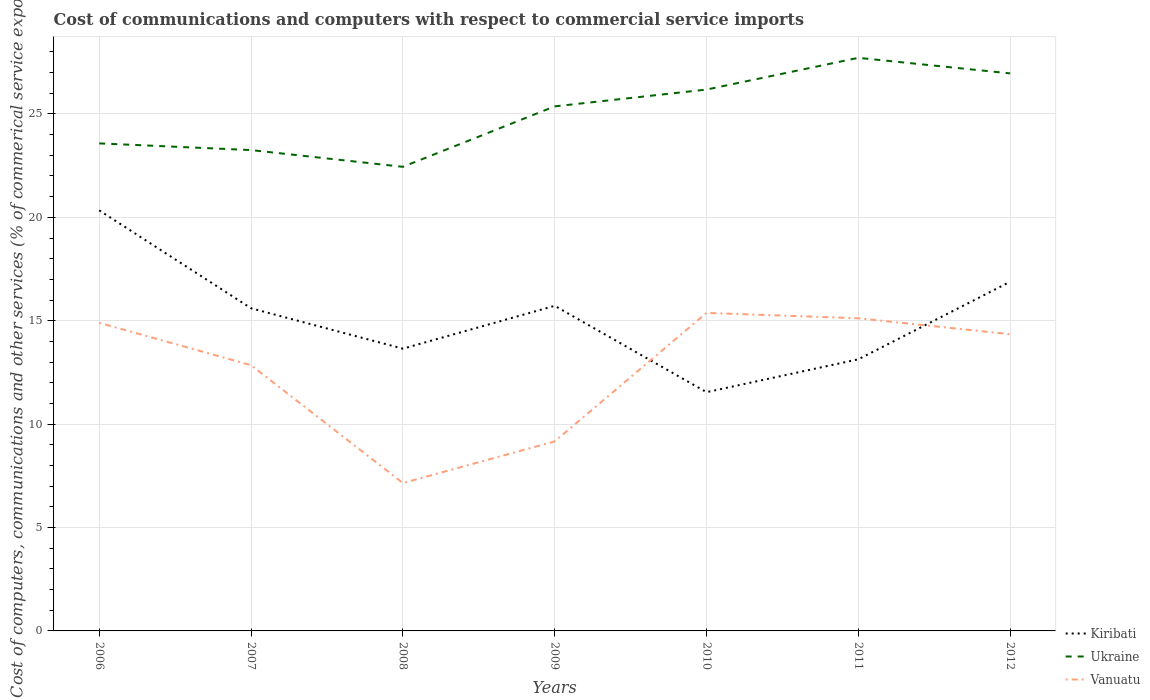Across all years, what is the maximum cost of communications and computers in Ukraine?
Make the answer very short. 22.44. What is the total cost of communications and computers in Vanuatu in the graph?
Offer a very short reply. -2.27. What is the difference between the highest and the second highest cost of communications and computers in Vanuatu?
Offer a very short reply. 8.23. What is the difference between the highest and the lowest cost of communications and computers in Kiribati?
Give a very brief answer. 4. Is the cost of communications and computers in Ukraine strictly greater than the cost of communications and computers in Kiribati over the years?
Your answer should be very brief. No. How many lines are there?
Provide a succinct answer. 3. How many years are there in the graph?
Your answer should be compact. 7. What is the difference between two consecutive major ticks on the Y-axis?
Keep it short and to the point. 5. Are the values on the major ticks of Y-axis written in scientific E-notation?
Keep it short and to the point. No. Does the graph contain any zero values?
Give a very brief answer. No. What is the title of the graph?
Make the answer very short. Cost of communications and computers with respect to commercial service imports. What is the label or title of the X-axis?
Your answer should be very brief. Years. What is the label or title of the Y-axis?
Keep it short and to the point. Cost of computers, communications and other services (% of commerical service exports). What is the Cost of computers, communications and other services (% of commerical service exports) of Kiribati in 2006?
Provide a succinct answer. 20.34. What is the Cost of computers, communications and other services (% of commerical service exports) in Ukraine in 2006?
Your answer should be compact. 23.58. What is the Cost of computers, communications and other services (% of commerical service exports) in Vanuatu in 2006?
Offer a very short reply. 14.9. What is the Cost of computers, communications and other services (% of commerical service exports) of Kiribati in 2007?
Give a very brief answer. 15.6. What is the Cost of computers, communications and other services (% of commerical service exports) in Ukraine in 2007?
Your answer should be very brief. 23.25. What is the Cost of computers, communications and other services (% of commerical service exports) of Vanuatu in 2007?
Your answer should be compact. 12.85. What is the Cost of computers, communications and other services (% of commerical service exports) in Kiribati in 2008?
Make the answer very short. 13.65. What is the Cost of computers, communications and other services (% of commerical service exports) of Ukraine in 2008?
Give a very brief answer. 22.44. What is the Cost of computers, communications and other services (% of commerical service exports) in Vanuatu in 2008?
Provide a succinct answer. 7.15. What is the Cost of computers, communications and other services (% of commerical service exports) in Kiribati in 2009?
Your answer should be very brief. 15.72. What is the Cost of computers, communications and other services (% of commerical service exports) in Ukraine in 2009?
Your answer should be very brief. 25.37. What is the Cost of computers, communications and other services (% of commerical service exports) in Vanuatu in 2009?
Your answer should be compact. 9.16. What is the Cost of computers, communications and other services (% of commerical service exports) in Kiribati in 2010?
Give a very brief answer. 11.55. What is the Cost of computers, communications and other services (% of commerical service exports) in Ukraine in 2010?
Ensure brevity in your answer.  26.18. What is the Cost of computers, communications and other services (% of commerical service exports) of Vanuatu in 2010?
Give a very brief answer. 15.38. What is the Cost of computers, communications and other services (% of commerical service exports) in Kiribati in 2011?
Your answer should be very brief. 13.13. What is the Cost of computers, communications and other services (% of commerical service exports) of Ukraine in 2011?
Your response must be concise. 27.71. What is the Cost of computers, communications and other services (% of commerical service exports) in Vanuatu in 2011?
Give a very brief answer. 15.12. What is the Cost of computers, communications and other services (% of commerical service exports) in Kiribati in 2012?
Make the answer very short. 16.89. What is the Cost of computers, communications and other services (% of commerical service exports) in Ukraine in 2012?
Make the answer very short. 26.96. What is the Cost of computers, communications and other services (% of commerical service exports) in Vanuatu in 2012?
Ensure brevity in your answer.  14.35. Across all years, what is the maximum Cost of computers, communications and other services (% of commerical service exports) in Kiribati?
Your answer should be very brief. 20.34. Across all years, what is the maximum Cost of computers, communications and other services (% of commerical service exports) of Ukraine?
Your answer should be compact. 27.71. Across all years, what is the maximum Cost of computers, communications and other services (% of commerical service exports) of Vanuatu?
Your answer should be very brief. 15.38. Across all years, what is the minimum Cost of computers, communications and other services (% of commerical service exports) in Kiribati?
Offer a very short reply. 11.55. Across all years, what is the minimum Cost of computers, communications and other services (% of commerical service exports) in Ukraine?
Your answer should be compact. 22.44. Across all years, what is the minimum Cost of computers, communications and other services (% of commerical service exports) in Vanuatu?
Provide a short and direct response. 7.15. What is the total Cost of computers, communications and other services (% of commerical service exports) of Kiribati in the graph?
Provide a succinct answer. 106.88. What is the total Cost of computers, communications and other services (% of commerical service exports) of Ukraine in the graph?
Your answer should be very brief. 175.49. What is the total Cost of computers, communications and other services (% of commerical service exports) in Vanuatu in the graph?
Offer a very short reply. 88.91. What is the difference between the Cost of computers, communications and other services (% of commerical service exports) in Kiribati in 2006 and that in 2007?
Offer a terse response. 4.73. What is the difference between the Cost of computers, communications and other services (% of commerical service exports) of Ukraine in 2006 and that in 2007?
Offer a very short reply. 0.32. What is the difference between the Cost of computers, communications and other services (% of commerical service exports) in Vanuatu in 2006 and that in 2007?
Provide a succinct answer. 2.05. What is the difference between the Cost of computers, communications and other services (% of commerical service exports) in Kiribati in 2006 and that in 2008?
Your response must be concise. 6.69. What is the difference between the Cost of computers, communications and other services (% of commerical service exports) of Ukraine in 2006 and that in 2008?
Provide a short and direct response. 1.13. What is the difference between the Cost of computers, communications and other services (% of commerical service exports) of Vanuatu in 2006 and that in 2008?
Offer a very short reply. 7.75. What is the difference between the Cost of computers, communications and other services (% of commerical service exports) in Kiribati in 2006 and that in 2009?
Make the answer very short. 4.62. What is the difference between the Cost of computers, communications and other services (% of commerical service exports) of Ukraine in 2006 and that in 2009?
Provide a short and direct response. -1.79. What is the difference between the Cost of computers, communications and other services (% of commerical service exports) of Vanuatu in 2006 and that in 2009?
Your answer should be compact. 5.73. What is the difference between the Cost of computers, communications and other services (% of commerical service exports) of Kiribati in 2006 and that in 2010?
Provide a short and direct response. 8.79. What is the difference between the Cost of computers, communications and other services (% of commerical service exports) of Ukraine in 2006 and that in 2010?
Provide a succinct answer. -2.6. What is the difference between the Cost of computers, communications and other services (% of commerical service exports) in Vanuatu in 2006 and that in 2010?
Provide a succinct answer. -0.48. What is the difference between the Cost of computers, communications and other services (% of commerical service exports) in Kiribati in 2006 and that in 2011?
Ensure brevity in your answer.  7.2. What is the difference between the Cost of computers, communications and other services (% of commerical service exports) in Ukraine in 2006 and that in 2011?
Keep it short and to the point. -4.14. What is the difference between the Cost of computers, communications and other services (% of commerical service exports) in Vanuatu in 2006 and that in 2011?
Ensure brevity in your answer.  -0.22. What is the difference between the Cost of computers, communications and other services (% of commerical service exports) of Kiribati in 2006 and that in 2012?
Your answer should be compact. 3.45. What is the difference between the Cost of computers, communications and other services (% of commerical service exports) in Ukraine in 2006 and that in 2012?
Keep it short and to the point. -3.39. What is the difference between the Cost of computers, communications and other services (% of commerical service exports) in Vanuatu in 2006 and that in 2012?
Offer a very short reply. 0.55. What is the difference between the Cost of computers, communications and other services (% of commerical service exports) in Kiribati in 2007 and that in 2008?
Ensure brevity in your answer.  1.95. What is the difference between the Cost of computers, communications and other services (% of commerical service exports) in Ukraine in 2007 and that in 2008?
Your answer should be compact. 0.81. What is the difference between the Cost of computers, communications and other services (% of commerical service exports) in Vanuatu in 2007 and that in 2008?
Ensure brevity in your answer.  5.7. What is the difference between the Cost of computers, communications and other services (% of commerical service exports) in Kiribati in 2007 and that in 2009?
Offer a terse response. -0.12. What is the difference between the Cost of computers, communications and other services (% of commerical service exports) in Ukraine in 2007 and that in 2009?
Make the answer very short. -2.11. What is the difference between the Cost of computers, communications and other services (% of commerical service exports) of Vanuatu in 2007 and that in 2009?
Your response must be concise. 3.68. What is the difference between the Cost of computers, communications and other services (% of commerical service exports) in Kiribati in 2007 and that in 2010?
Keep it short and to the point. 4.06. What is the difference between the Cost of computers, communications and other services (% of commerical service exports) of Ukraine in 2007 and that in 2010?
Your response must be concise. -2.93. What is the difference between the Cost of computers, communications and other services (% of commerical service exports) of Vanuatu in 2007 and that in 2010?
Make the answer very short. -2.53. What is the difference between the Cost of computers, communications and other services (% of commerical service exports) in Kiribati in 2007 and that in 2011?
Offer a very short reply. 2.47. What is the difference between the Cost of computers, communications and other services (% of commerical service exports) in Ukraine in 2007 and that in 2011?
Provide a short and direct response. -4.46. What is the difference between the Cost of computers, communications and other services (% of commerical service exports) in Vanuatu in 2007 and that in 2011?
Your answer should be very brief. -2.27. What is the difference between the Cost of computers, communications and other services (% of commerical service exports) of Kiribati in 2007 and that in 2012?
Keep it short and to the point. -1.28. What is the difference between the Cost of computers, communications and other services (% of commerical service exports) in Ukraine in 2007 and that in 2012?
Offer a terse response. -3.71. What is the difference between the Cost of computers, communications and other services (% of commerical service exports) of Vanuatu in 2007 and that in 2012?
Make the answer very short. -1.5. What is the difference between the Cost of computers, communications and other services (% of commerical service exports) of Kiribati in 2008 and that in 2009?
Your response must be concise. -2.07. What is the difference between the Cost of computers, communications and other services (% of commerical service exports) in Ukraine in 2008 and that in 2009?
Provide a short and direct response. -2.92. What is the difference between the Cost of computers, communications and other services (% of commerical service exports) of Vanuatu in 2008 and that in 2009?
Ensure brevity in your answer.  -2.01. What is the difference between the Cost of computers, communications and other services (% of commerical service exports) of Kiribati in 2008 and that in 2010?
Offer a terse response. 2.1. What is the difference between the Cost of computers, communications and other services (% of commerical service exports) of Ukraine in 2008 and that in 2010?
Your response must be concise. -3.74. What is the difference between the Cost of computers, communications and other services (% of commerical service exports) of Vanuatu in 2008 and that in 2010?
Give a very brief answer. -8.23. What is the difference between the Cost of computers, communications and other services (% of commerical service exports) of Kiribati in 2008 and that in 2011?
Keep it short and to the point. 0.52. What is the difference between the Cost of computers, communications and other services (% of commerical service exports) of Ukraine in 2008 and that in 2011?
Offer a very short reply. -5.27. What is the difference between the Cost of computers, communications and other services (% of commerical service exports) in Vanuatu in 2008 and that in 2011?
Offer a very short reply. -7.97. What is the difference between the Cost of computers, communications and other services (% of commerical service exports) in Kiribati in 2008 and that in 2012?
Make the answer very short. -3.24. What is the difference between the Cost of computers, communications and other services (% of commerical service exports) in Ukraine in 2008 and that in 2012?
Provide a short and direct response. -4.52. What is the difference between the Cost of computers, communications and other services (% of commerical service exports) of Vanuatu in 2008 and that in 2012?
Give a very brief answer. -7.2. What is the difference between the Cost of computers, communications and other services (% of commerical service exports) in Kiribati in 2009 and that in 2010?
Offer a terse response. 4.18. What is the difference between the Cost of computers, communications and other services (% of commerical service exports) in Ukraine in 2009 and that in 2010?
Ensure brevity in your answer.  -0.81. What is the difference between the Cost of computers, communications and other services (% of commerical service exports) of Vanuatu in 2009 and that in 2010?
Provide a short and direct response. -6.22. What is the difference between the Cost of computers, communications and other services (% of commerical service exports) of Kiribati in 2009 and that in 2011?
Give a very brief answer. 2.59. What is the difference between the Cost of computers, communications and other services (% of commerical service exports) of Ukraine in 2009 and that in 2011?
Your response must be concise. -2.35. What is the difference between the Cost of computers, communications and other services (% of commerical service exports) in Vanuatu in 2009 and that in 2011?
Keep it short and to the point. -5.95. What is the difference between the Cost of computers, communications and other services (% of commerical service exports) in Kiribati in 2009 and that in 2012?
Your response must be concise. -1.16. What is the difference between the Cost of computers, communications and other services (% of commerical service exports) of Ukraine in 2009 and that in 2012?
Keep it short and to the point. -1.6. What is the difference between the Cost of computers, communications and other services (% of commerical service exports) in Vanuatu in 2009 and that in 2012?
Offer a terse response. -5.18. What is the difference between the Cost of computers, communications and other services (% of commerical service exports) of Kiribati in 2010 and that in 2011?
Provide a short and direct response. -1.59. What is the difference between the Cost of computers, communications and other services (% of commerical service exports) in Ukraine in 2010 and that in 2011?
Provide a succinct answer. -1.53. What is the difference between the Cost of computers, communications and other services (% of commerical service exports) of Vanuatu in 2010 and that in 2011?
Give a very brief answer. 0.26. What is the difference between the Cost of computers, communications and other services (% of commerical service exports) of Kiribati in 2010 and that in 2012?
Give a very brief answer. -5.34. What is the difference between the Cost of computers, communications and other services (% of commerical service exports) of Ukraine in 2010 and that in 2012?
Provide a succinct answer. -0.78. What is the difference between the Cost of computers, communications and other services (% of commerical service exports) of Vanuatu in 2010 and that in 2012?
Give a very brief answer. 1.03. What is the difference between the Cost of computers, communications and other services (% of commerical service exports) of Kiribati in 2011 and that in 2012?
Provide a short and direct response. -3.75. What is the difference between the Cost of computers, communications and other services (% of commerical service exports) of Ukraine in 2011 and that in 2012?
Give a very brief answer. 0.75. What is the difference between the Cost of computers, communications and other services (% of commerical service exports) in Vanuatu in 2011 and that in 2012?
Ensure brevity in your answer.  0.77. What is the difference between the Cost of computers, communications and other services (% of commerical service exports) of Kiribati in 2006 and the Cost of computers, communications and other services (% of commerical service exports) of Ukraine in 2007?
Provide a succinct answer. -2.92. What is the difference between the Cost of computers, communications and other services (% of commerical service exports) of Kiribati in 2006 and the Cost of computers, communications and other services (% of commerical service exports) of Vanuatu in 2007?
Your answer should be very brief. 7.49. What is the difference between the Cost of computers, communications and other services (% of commerical service exports) in Ukraine in 2006 and the Cost of computers, communications and other services (% of commerical service exports) in Vanuatu in 2007?
Give a very brief answer. 10.73. What is the difference between the Cost of computers, communications and other services (% of commerical service exports) in Kiribati in 2006 and the Cost of computers, communications and other services (% of commerical service exports) in Ukraine in 2008?
Provide a short and direct response. -2.11. What is the difference between the Cost of computers, communications and other services (% of commerical service exports) of Kiribati in 2006 and the Cost of computers, communications and other services (% of commerical service exports) of Vanuatu in 2008?
Offer a terse response. 13.18. What is the difference between the Cost of computers, communications and other services (% of commerical service exports) of Ukraine in 2006 and the Cost of computers, communications and other services (% of commerical service exports) of Vanuatu in 2008?
Keep it short and to the point. 16.42. What is the difference between the Cost of computers, communications and other services (% of commerical service exports) in Kiribati in 2006 and the Cost of computers, communications and other services (% of commerical service exports) in Ukraine in 2009?
Your answer should be compact. -5.03. What is the difference between the Cost of computers, communications and other services (% of commerical service exports) of Kiribati in 2006 and the Cost of computers, communications and other services (% of commerical service exports) of Vanuatu in 2009?
Offer a terse response. 11.17. What is the difference between the Cost of computers, communications and other services (% of commerical service exports) of Ukraine in 2006 and the Cost of computers, communications and other services (% of commerical service exports) of Vanuatu in 2009?
Keep it short and to the point. 14.41. What is the difference between the Cost of computers, communications and other services (% of commerical service exports) of Kiribati in 2006 and the Cost of computers, communications and other services (% of commerical service exports) of Ukraine in 2010?
Your answer should be very brief. -5.84. What is the difference between the Cost of computers, communications and other services (% of commerical service exports) of Kiribati in 2006 and the Cost of computers, communications and other services (% of commerical service exports) of Vanuatu in 2010?
Your response must be concise. 4.96. What is the difference between the Cost of computers, communications and other services (% of commerical service exports) of Ukraine in 2006 and the Cost of computers, communications and other services (% of commerical service exports) of Vanuatu in 2010?
Provide a succinct answer. 8.2. What is the difference between the Cost of computers, communications and other services (% of commerical service exports) of Kiribati in 2006 and the Cost of computers, communications and other services (% of commerical service exports) of Ukraine in 2011?
Your response must be concise. -7.38. What is the difference between the Cost of computers, communications and other services (% of commerical service exports) of Kiribati in 2006 and the Cost of computers, communications and other services (% of commerical service exports) of Vanuatu in 2011?
Your response must be concise. 5.22. What is the difference between the Cost of computers, communications and other services (% of commerical service exports) in Ukraine in 2006 and the Cost of computers, communications and other services (% of commerical service exports) in Vanuatu in 2011?
Provide a short and direct response. 8.46. What is the difference between the Cost of computers, communications and other services (% of commerical service exports) of Kiribati in 2006 and the Cost of computers, communications and other services (% of commerical service exports) of Ukraine in 2012?
Your answer should be compact. -6.62. What is the difference between the Cost of computers, communications and other services (% of commerical service exports) in Kiribati in 2006 and the Cost of computers, communications and other services (% of commerical service exports) in Vanuatu in 2012?
Make the answer very short. 5.99. What is the difference between the Cost of computers, communications and other services (% of commerical service exports) of Ukraine in 2006 and the Cost of computers, communications and other services (% of commerical service exports) of Vanuatu in 2012?
Offer a terse response. 9.23. What is the difference between the Cost of computers, communications and other services (% of commerical service exports) in Kiribati in 2007 and the Cost of computers, communications and other services (% of commerical service exports) in Ukraine in 2008?
Make the answer very short. -6.84. What is the difference between the Cost of computers, communications and other services (% of commerical service exports) of Kiribati in 2007 and the Cost of computers, communications and other services (% of commerical service exports) of Vanuatu in 2008?
Your answer should be compact. 8.45. What is the difference between the Cost of computers, communications and other services (% of commerical service exports) in Ukraine in 2007 and the Cost of computers, communications and other services (% of commerical service exports) in Vanuatu in 2008?
Your answer should be compact. 16.1. What is the difference between the Cost of computers, communications and other services (% of commerical service exports) in Kiribati in 2007 and the Cost of computers, communications and other services (% of commerical service exports) in Ukraine in 2009?
Ensure brevity in your answer.  -9.76. What is the difference between the Cost of computers, communications and other services (% of commerical service exports) of Kiribati in 2007 and the Cost of computers, communications and other services (% of commerical service exports) of Vanuatu in 2009?
Make the answer very short. 6.44. What is the difference between the Cost of computers, communications and other services (% of commerical service exports) in Ukraine in 2007 and the Cost of computers, communications and other services (% of commerical service exports) in Vanuatu in 2009?
Give a very brief answer. 14.09. What is the difference between the Cost of computers, communications and other services (% of commerical service exports) of Kiribati in 2007 and the Cost of computers, communications and other services (% of commerical service exports) of Ukraine in 2010?
Provide a short and direct response. -10.58. What is the difference between the Cost of computers, communications and other services (% of commerical service exports) of Kiribati in 2007 and the Cost of computers, communications and other services (% of commerical service exports) of Vanuatu in 2010?
Your response must be concise. 0.22. What is the difference between the Cost of computers, communications and other services (% of commerical service exports) of Ukraine in 2007 and the Cost of computers, communications and other services (% of commerical service exports) of Vanuatu in 2010?
Keep it short and to the point. 7.87. What is the difference between the Cost of computers, communications and other services (% of commerical service exports) in Kiribati in 2007 and the Cost of computers, communications and other services (% of commerical service exports) in Ukraine in 2011?
Your response must be concise. -12.11. What is the difference between the Cost of computers, communications and other services (% of commerical service exports) of Kiribati in 2007 and the Cost of computers, communications and other services (% of commerical service exports) of Vanuatu in 2011?
Offer a terse response. 0.48. What is the difference between the Cost of computers, communications and other services (% of commerical service exports) in Ukraine in 2007 and the Cost of computers, communications and other services (% of commerical service exports) in Vanuatu in 2011?
Ensure brevity in your answer.  8.13. What is the difference between the Cost of computers, communications and other services (% of commerical service exports) of Kiribati in 2007 and the Cost of computers, communications and other services (% of commerical service exports) of Ukraine in 2012?
Offer a very short reply. -11.36. What is the difference between the Cost of computers, communications and other services (% of commerical service exports) of Kiribati in 2007 and the Cost of computers, communications and other services (% of commerical service exports) of Vanuatu in 2012?
Make the answer very short. 1.25. What is the difference between the Cost of computers, communications and other services (% of commerical service exports) in Ukraine in 2007 and the Cost of computers, communications and other services (% of commerical service exports) in Vanuatu in 2012?
Ensure brevity in your answer.  8.9. What is the difference between the Cost of computers, communications and other services (% of commerical service exports) of Kiribati in 2008 and the Cost of computers, communications and other services (% of commerical service exports) of Ukraine in 2009?
Offer a very short reply. -11.72. What is the difference between the Cost of computers, communications and other services (% of commerical service exports) in Kiribati in 2008 and the Cost of computers, communications and other services (% of commerical service exports) in Vanuatu in 2009?
Your response must be concise. 4.49. What is the difference between the Cost of computers, communications and other services (% of commerical service exports) of Ukraine in 2008 and the Cost of computers, communications and other services (% of commerical service exports) of Vanuatu in 2009?
Your response must be concise. 13.28. What is the difference between the Cost of computers, communications and other services (% of commerical service exports) in Kiribati in 2008 and the Cost of computers, communications and other services (% of commerical service exports) in Ukraine in 2010?
Your response must be concise. -12.53. What is the difference between the Cost of computers, communications and other services (% of commerical service exports) in Kiribati in 2008 and the Cost of computers, communications and other services (% of commerical service exports) in Vanuatu in 2010?
Your response must be concise. -1.73. What is the difference between the Cost of computers, communications and other services (% of commerical service exports) in Ukraine in 2008 and the Cost of computers, communications and other services (% of commerical service exports) in Vanuatu in 2010?
Provide a succinct answer. 7.06. What is the difference between the Cost of computers, communications and other services (% of commerical service exports) of Kiribati in 2008 and the Cost of computers, communications and other services (% of commerical service exports) of Ukraine in 2011?
Keep it short and to the point. -14.06. What is the difference between the Cost of computers, communications and other services (% of commerical service exports) in Kiribati in 2008 and the Cost of computers, communications and other services (% of commerical service exports) in Vanuatu in 2011?
Provide a short and direct response. -1.47. What is the difference between the Cost of computers, communications and other services (% of commerical service exports) in Ukraine in 2008 and the Cost of computers, communications and other services (% of commerical service exports) in Vanuatu in 2011?
Give a very brief answer. 7.32. What is the difference between the Cost of computers, communications and other services (% of commerical service exports) in Kiribati in 2008 and the Cost of computers, communications and other services (% of commerical service exports) in Ukraine in 2012?
Ensure brevity in your answer.  -13.31. What is the difference between the Cost of computers, communications and other services (% of commerical service exports) in Kiribati in 2008 and the Cost of computers, communications and other services (% of commerical service exports) in Vanuatu in 2012?
Offer a terse response. -0.7. What is the difference between the Cost of computers, communications and other services (% of commerical service exports) of Ukraine in 2008 and the Cost of computers, communications and other services (% of commerical service exports) of Vanuatu in 2012?
Your answer should be very brief. 8.1. What is the difference between the Cost of computers, communications and other services (% of commerical service exports) in Kiribati in 2009 and the Cost of computers, communications and other services (% of commerical service exports) in Ukraine in 2010?
Offer a very short reply. -10.46. What is the difference between the Cost of computers, communications and other services (% of commerical service exports) in Kiribati in 2009 and the Cost of computers, communications and other services (% of commerical service exports) in Vanuatu in 2010?
Provide a succinct answer. 0.34. What is the difference between the Cost of computers, communications and other services (% of commerical service exports) of Ukraine in 2009 and the Cost of computers, communications and other services (% of commerical service exports) of Vanuatu in 2010?
Your answer should be compact. 9.99. What is the difference between the Cost of computers, communications and other services (% of commerical service exports) of Kiribati in 2009 and the Cost of computers, communications and other services (% of commerical service exports) of Ukraine in 2011?
Your answer should be compact. -11.99. What is the difference between the Cost of computers, communications and other services (% of commerical service exports) in Kiribati in 2009 and the Cost of computers, communications and other services (% of commerical service exports) in Vanuatu in 2011?
Your answer should be very brief. 0.6. What is the difference between the Cost of computers, communications and other services (% of commerical service exports) in Ukraine in 2009 and the Cost of computers, communications and other services (% of commerical service exports) in Vanuatu in 2011?
Your answer should be compact. 10.25. What is the difference between the Cost of computers, communications and other services (% of commerical service exports) in Kiribati in 2009 and the Cost of computers, communications and other services (% of commerical service exports) in Ukraine in 2012?
Your answer should be very brief. -11.24. What is the difference between the Cost of computers, communications and other services (% of commerical service exports) in Kiribati in 2009 and the Cost of computers, communications and other services (% of commerical service exports) in Vanuatu in 2012?
Ensure brevity in your answer.  1.37. What is the difference between the Cost of computers, communications and other services (% of commerical service exports) in Ukraine in 2009 and the Cost of computers, communications and other services (% of commerical service exports) in Vanuatu in 2012?
Give a very brief answer. 11.02. What is the difference between the Cost of computers, communications and other services (% of commerical service exports) in Kiribati in 2010 and the Cost of computers, communications and other services (% of commerical service exports) in Ukraine in 2011?
Make the answer very short. -16.17. What is the difference between the Cost of computers, communications and other services (% of commerical service exports) in Kiribati in 2010 and the Cost of computers, communications and other services (% of commerical service exports) in Vanuatu in 2011?
Your response must be concise. -3.57. What is the difference between the Cost of computers, communications and other services (% of commerical service exports) of Ukraine in 2010 and the Cost of computers, communications and other services (% of commerical service exports) of Vanuatu in 2011?
Offer a very short reply. 11.06. What is the difference between the Cost of computers, communications and other services (% of commerical service exports) of Kiribati in 2010 and the Cost of computers, communications and other services (% of commerical service exports) of Ukraine in 2012?
Offer a terse response. -15.42. What is the difference between the Cost of computers, communications and other services (% of commerical service exports) of Kiribati in 2010 and the Cost of computers, communications and other services (% of commerical service exports) of Vanuatu in 2012?
Make the answer very short. -2.8. What is the difference between the Cost of computers, communications and other services (% of commerical service exports) in Ukraine in 2010 and the Cost of computers, communications and other services (% of commerical service exports) in Vanuatu in 2012?
Make the answer very short. 11.83. What is the difference between the Cost of computers, communications and other services (% of commerical service exports) in Kiribati in 2011 and the Cost of computers, communications and other services (% of commerical service exports) in Ukraine in 2012?
Provide a succinct answer. -13.83. What is the difference between the Cost of computers, communications and other services (% of commerical service exports) of Kiribati in 2011 and the Cost of computers, communications and other services (% of commerical service exports) of Vanuatu in 2012?
Offer a very short reply. -1.21. What is the difference between the Cost of computers, communications and other services (% of commerical service exports) in Ukraine in 2011 and the Cost of computers, communications and other services (% of commerical service exports) in Vanuatu in 2012?
Your answer should be compact. 13.37. What is the average Cost of computers, communications and other services (% of commerical service exports) of Kiribati per year?
Your response must be concise. 15.27. What is the average Cost of computers, communications and other services (% of commerical service exports) in Ukraine per year?
Your answer should be compact. 25.07. What is the average Cost of computers, communications and other services (% of commerical service exports) in Vanuatu per year?
Keep it short and to the point. 12.7. In the year 2006, what is the difference between the Cost of computers, communications and other services (% of commerical service exports) of Kiribati and Cost of computers, communications and other services (% of commerical service exports) of Ukraine?
Offer a very short reply. -3.24. In the year 2006, what is the difference between the Cost of computers, communications and other services (% of commerical service exports) of Kiribati and Cost of computers, communications and other services (% of commerical service exports) of Vanuatu?
Provide a short and direct response. 5.44. In the year 2006, what is the difference between the Cost of computers, communications and other services (% of commerical service exports) of Ukraine and Cost of computers, communications and other services (% of commerical service exports) of Vanuatu?
Your response must be concise. 8.68. In the year 2007, what is the difference between the Cost of computers, communications and other services (% of commerical service exports) in Kiribati and Cost of computers, communications and other services (% of commerical service exports) in Ukraine?
Your response must be concise. -7.65. In the year 2007, what is the difference between the Cost of computers, communications and other services (% of commerical service exports) in Kiribati and Cost of computers, communications and other services (% of commerical service exports) in Vanuatu?
Provide a short and direct response. 2.75. In the year 2007, what is the difference between the Cost of computers, communications and other services (% of commerical service exports) in Ukraine and Cost of computers, communications and other services (% of commerical service exports) in Vanuatu?
Your answer should be very brief. 10.4. In the year 2008, what is the difference between the Cost of computers, communications and other services (% of commerical service exports) of Kiribati and Cost of computers, communications and other services (% of commerical service exports) of Ukraine?
Your answer should be compact. -8.79. In the year 2008, what is the difference between the Cost of computers, communications and other services (% of commerical service exports) in Kiribati and Cost of computers, communications and other services (% of commerical service exports) in Vanuatu?
Provide a short and direct response. 6.5. In the year 2008, what is the difference between the Cost of computers, communications and other services (% of commerical service exports) in Ukraine and Cost of computers, communications and other services (% of commerical service exports) in Vanuatu?
Provide a succinct answer. 15.29. In the year 2009, what is the difference between the Cost of computers, communications and other services (% of commerical service exports) in Kiribati and Cost of computers, communications and other services (% of commerical service exports) in Ukraine?
Provide a succinct answer. -9.65. In the year 2009, what is the difference between the Cost of computers, communications and other services (% of commerical service exports) of Kiribati and Cost of computers, communications and other services (% of commerical service exports) of Vanuatu?
Your response must be concise. 6.56. In the year 2009, what is the difference between the Cost of computers, communications and other services (% of commerical service exports) in Ukraine and Cost of computers, communications and other services (% of commerical service exports) in Vanuatu?
Your response must be concise. 16.2. In the year 2010, what is the difference between the Cost of computers, communications and other services (% of commerical service exports) of Kiribati and Cost of computers, communications and other services (% of commerical service exports) of Ukraine?
Offer a very short reply. -14.63. In the year 2010, what is the difference between the Cost of computers, communications and other services (% of commerical service exports) of Kiribati and Cost of computers, communications and other services (% of commerical service exports) of Vanuatu?
Keep it short and to the point. -3.83. In the year 2010, what is the difference between the Cost of computers, communications and other services (% of commerical service exports) in Ukraine and Cost of computers, communications and other services (% of commerical service exports) in Vanuatu?
Provide a succinct answer. 10.8. In the year 2011, what is the difference between the Cost of computers, communications and other services (% of commerical service exports) of Kiribati and Cost of computers, communications and other services (% of commerical service exports) of Ukraine?
Offer a terse response. -14.58. In the year 2011, what is the difference between the Cost of computers, communications and other services (% of commerical service exports) of Kiribati and Cost of computers, communications and other services (% of commerical service exports) of Vanuatu?
Ensure brevity in your answer.  -1.98. In the year 2011, what is the difference between the Cost of computers, communications and other services (% of commerical service exports) of Ukraine and Cost of computers, communications and other services (% of commerical service exports) of Vanuatu?
Make the answer very short. 12.6. In the year 2012, what is the difference between the Cost of computers, communications and other services (% of commerical service exports) of Kiribati and Cost of computers, communications and other services (% of commerical service exports) of Ukraine?
Keep it short and to the point. -10.08. In the year 2012, what is the difference between the Cost of computers, communications and other services (% of commerical service exports) of Kiribati and Cost of computers, communications and other services (% of commerical service exports) of Vanuatu?
Offer a terse response. 2.54. In the year 2012, what is the difference between the Cost of computers, communications and other services (% of commerical service exports) in Ukraine and Cost of computers, communications and other services (% of commerical service exports) in Vanuatu?
Make the answer very short. 12.61. What is the ratio of the Cost of computers, communications and other services (% of commerical service exports) in Kiribati in 2006 to that in 2007?
Offer a terse response. 1.3. What is the ratio of the Cost of computers, communications and other services (% of commerical service exports) in Ukraine in 2006 to that in 2007?
Offer a terse response. 1.01. What is the ratio of the Cost of computers, communications and other services (% of commerical service exports) in Vanuatu in 2006 to that in 2007?
Your answer should be compact. 1.16. What is the ratio of the Cost of computers, communications and other services (% of commerical service exports) of Kiribati in 2006 to that in 2008?
Provide a short and direct response. 1.49. What is the ratio of the Cost of computers, communications and other services (% of commerical service exports) of Ukraine in 2006 to that in 2008?
Your response must be concise. 1.05. What is the ratio of the Cost of computers, communications and other services (% of commerical service exports) in Vanuatu in 2006 to that in 2008?
Provide a short and direct response. 2.08. What is the ratio of the Cost of computers, communications and other services (% of commerical service exports) of Kiribati in 2006 to that in 2009?
Offer a terse response. 1.29. What is the ratio of the Cost of computers, communications and other services (% of commerical service exports) in Ukraine in 2006 to that in 2009?
Ensure brevity in your answer.  0.93. What is the ratio of the Cost of computers, communications and other services (% of commerical service exports) of Vanuatu in 2006 to that in 2009?
Your answer should be very brief. 1.63. What is the ratio of the Cost of computers, communications and other services (% of commerical service exports) of Kiribati in 2006 to that in 2010?
Ensure brevity in your answer.  1.76. What is the ratio of the Cost of computers, communications and other services (% of commerical service exports) of Ukraine in 2006 to that in 2010?
Ensure brevity in your answer.  0.9. What is the ratio of the Cost of computers, communications and other services (% of commerical service exports) of Vanuatu in 2006 to that in 2010?
Ensure brevity in your answer.  0.97. What is the ratio of the Cost of computers, communications and other services (% of commerical service exports) of Kiribati in 2006 to that in 2011?
Provide a short and direct response. 1.55. What is the ratio of the Cost of computers, communications and other services (% of commerical service exports) in Ukraine in 2006 to that in 2011?
Offer a terse response. 0.85. What is the ratio of the Cost of computers, communications and other services (% of commerical service exports) in Vanuatu in 2006 to that in 2011?
Your answer should be compact. 0.99. What is the ratio of the Cost of computers, communications and other services (% of commerical service exports) of Kiribati in 2006 to that in 2012?
Give a very brief answer. 1.2. What is the ratio of the Cost of computers, communications and other services (% of commerical service exports) in Ukraine in 2006 to that in 2012?
Your response must be concise. 0.87. What is the ratio of the Cost of computers, communications and other services (% of commerical service exports) of Vanuatu in 2006 to that in 2012?
Keep it short and to the point. 1.04. What is the ratio of the Cost of computers, communications and other services (% of commerical service exports) in Kiribati in 2007 to that in 2008?
Make the answer very short. 1.14. What is the ratio of the Cost of computers, communications and other services (% of commerical service exports) in Ukraine in 2007 to that in 2008?
Your response must be concise. 1.04. What is the ratio of the Cost of computers, communications and other services (% of commerical service exports) in Vanuatu in 2007 to that in 2008?
Make the answer very short. 1.8. What is the ratio of the Cost of computers, communications and other services (% of commerical service exports) in Kiribati in 2007 to that in 2009?
Offer a terse response. 0.99. What is the ratio of the Cost of computers, communications and other services (% of commerical service exports) in Vanuatu in 2007 to that in 2009?
Your answer should be very brief. 1.4. What is the ratio of the Cost of computers, communications and other services (% of commerical service exports) in Kiribati in 2007 to that in 2010?
Provide a short and direct response. 1.35. What is the ratio of the Cost of computers, communications and other services (% of commerical service exports) in Ukraine in 2007 to that in 2010?
Your response must be concise. 0.89. What is the ratio of the Cost of computers, communications and other services (% of commerical service exports) of Vanuatu in 2007 to that in 2010?
Give a very brief answer. 0.84. What is the ratio of the Cost of computers, communications and other services (% of commerical service exports) of Kiribati in 2007 to that in 2011?
Your response must be concise. 1.19. What is the ratio of the Cost of computers, communications and other services (% of commerical service exports) in Ukraine in 2007 to that in 2011?
Your answer should be very brief. 0.84. What is the ratio of the Cost of computers, communications and other services (% of commerical service exports) of Vanuatu in 2007 to that in 2011?
Make the answer very short. 0.85. What is the ratio of the Cost of computers, communications and other services (% of commerical service exports) of Kiribati in 2007 to that in 2012?
Provide a short and direct response. 0.92. What is the ratio of the Cost of computers, communications and other services (% of commerical service exports) of Ukraine in 2007 to that in 2012?
Your answer should be very brief. 0.86. What is the ratio of the Cost of computers, communications and other services (% of commerical service exports) of Vanuatu in 2007 to that in 2012?
Your response must be concise. 0.9. What is the ratio of the Cost of computers, communications and other services (% of commerical service exports) of Kiribati in 2008 to that in 2009?
Keep it short and to the point. 0.87. What is the ratio of the Cost of computers, communications and other services (% of commerical service exports) in Ukraine in 2008 to that in 2009?
Provide a succinct answer. 0.88. What is the ratio of the Cost of computers, communications and other services (% of commerical service exports) of Vanuatu in 2008 to that in 2009?
Your answer should be very brief. 0.78. What is the ratio of the Cost of computers, communications and other services (% of commerical service exports) of Kiribati in 2008 to that in 2010?
Provide a short and direct response. 1.18. What is the ratio of the Cost of computers, communications and other services (% of commerical service exports) of Ukraine in 2008 to that in 2010?
Your response must be concise. 0.86. What is the ratio of the Cost of computers, communications and other services (% of commerical service exports) in Vanuatu in 2008 to that in 2010?
Provide a short and direct response. 0.47. What is the ratio of the Cost of computers, communications and other services (% of commerical service exports) in Kiribati in 2008 to that in 2011?
Offer a terse response. 1.04. What is the ratio of the Cost of computers, communications and other services (% of commerical service exports) of Ukraine in 2008 to that in 2011?
Your response must be concise. 0.81. What is the ratio of the Cost of computers, communications and other services (% of commerical service exports) in Vanuatu in 2008 to that in 2011?
Ensure brevity in your answer.  0.47. What is the ratio of the Cost of computers, communications and other services (% of commerical service exports) in Kiribati in 2008 to that in 2012?
Offer a terse response. 0.81. What is the ratio of the Cost of computers, communications and other services (% of commerical service exports) of Ukraine in 2008 to that in 2012?
Keep it short and to the point. 0.83. What is the ratio of the Cost of computers, communications and other services (% of commerical service exports) of Vanuatu in 2008 to that in 2012?
Provide a succinct answer. 0.5. What is the ratio of the Cost of computers, communications and other services (% of commerical service exports) of Kiribati in 2009 to that in 2010?
Provide a succinct answer. 1.36. What is the ratio of the Cost of computers, communications and other services (% of commerical service exports) in Ukraine in 2009 to that in 2010?
Give a very brief answer. 0.97. What is the ratio of the Cost of computers, communications and other services (% of commerical service exports) of Vanuatu in 2009 to that in 2010?
Make the answer very short. 0.6. What is the ratio of the Cost of computers, communications and other services (% of commerical service exports) of Kiribati in 2009 to that in 2011?
Keep it short and to the point. 1.2. What is the ratio of the Cost of computers, communications and other services (% of commerical service exports) in Ukraine in 2009 to that in 2011?
Offer a terse response. 0.92. What is the ratio of the Cost of computers, communications and other services (% of commerical service exports) in Vanuatu in 2009 to that in 2011?
Make the answer very short. 0.61. What is the ratio of the Cost of computers, communications and other services (% of commerical service exports) in Ukraine in 2009 to that in 2012?
Offer a very short reply. 0.94. What is the ratio of the Cost of computers, communications and other services (% of commerical service exports) in Vanuatu in 2009 to that in 2012?
Ensure brevity in your answer.  0.64. What is the ratio of the Cost of computers, communications and other services (% of commerical service exports) of Kiribati in 2010 to that in 2011?
Offer a very short reply. 0.88. What is the ratio of the Cost of computers, communications and other services (% of commerical service exports) of Ukraine in 2010 to that in 2011?
Keep it short and to the point. 0.94. What is the ratio of the Cost of computers, communications and other services (% of commerical service exports) of Vanuatu in 2010 to that in 2011?
Keep it short and to the point. 1.02. What is the ratio of the Cost of computers, communications and other services (% of commerical service exports) of Kiribati in 2010 to that in 2012?
Offer a very short reply. 0.68. What is the ratio of the Cost of computers, communications and other services (% of commerical service exports) of Vanuatu in 2010 to that in 2012?
Provide a succinct answer. 1.07. What is the ratio of the Cost of computers, communications and other services (% of commerical service exports) of Kiribati in 2011 to that in 2012?
Keep it short and to the point. 0.78. What is the ratio of the Cost of computers, communications and other services (% of commerical service exports) of Ukraine in 2011 to that in 2012?
Make the answer very short. 1.03. What is the ratio of the Cost of computers, communications and other services (% of commerical service exports) of Vanuatu in 2011 to that in 2012?
Make the answer very short. 1.05. What is the difference between the highest and the second highest Cost of computers, communications and other services (% of commerical service exports) in Kiribati?
Provide a succinct answer. 3.45. What is the difference between the highest and the second highest Cost of computers, communications and other services (% of commerical service exports) in Ukraine?
Provide a succinct answer. 0.75. What is the difference between the highest and the second highest Cost of computers, communications and other services (% of commerical service exports) in Vanuatu?
Provide a succinct answer. 0.26. What is the difference between the highest and the lowest Cost of computers, communications and other services (% of commerical service exports) of Kiribati?
Provide a short and direct response. 8.79. What is the difference between the highest and the lowest Cost of computers, communications and other services (% of commerical service exports) of Ukraine?
Your answer should be very brief. 5.27. What is the difference between the highest and the lowest Cost of computers, communications and other services (% of commerical service exports) in Vanuatu?
Give a very brief answer. 8.23. 